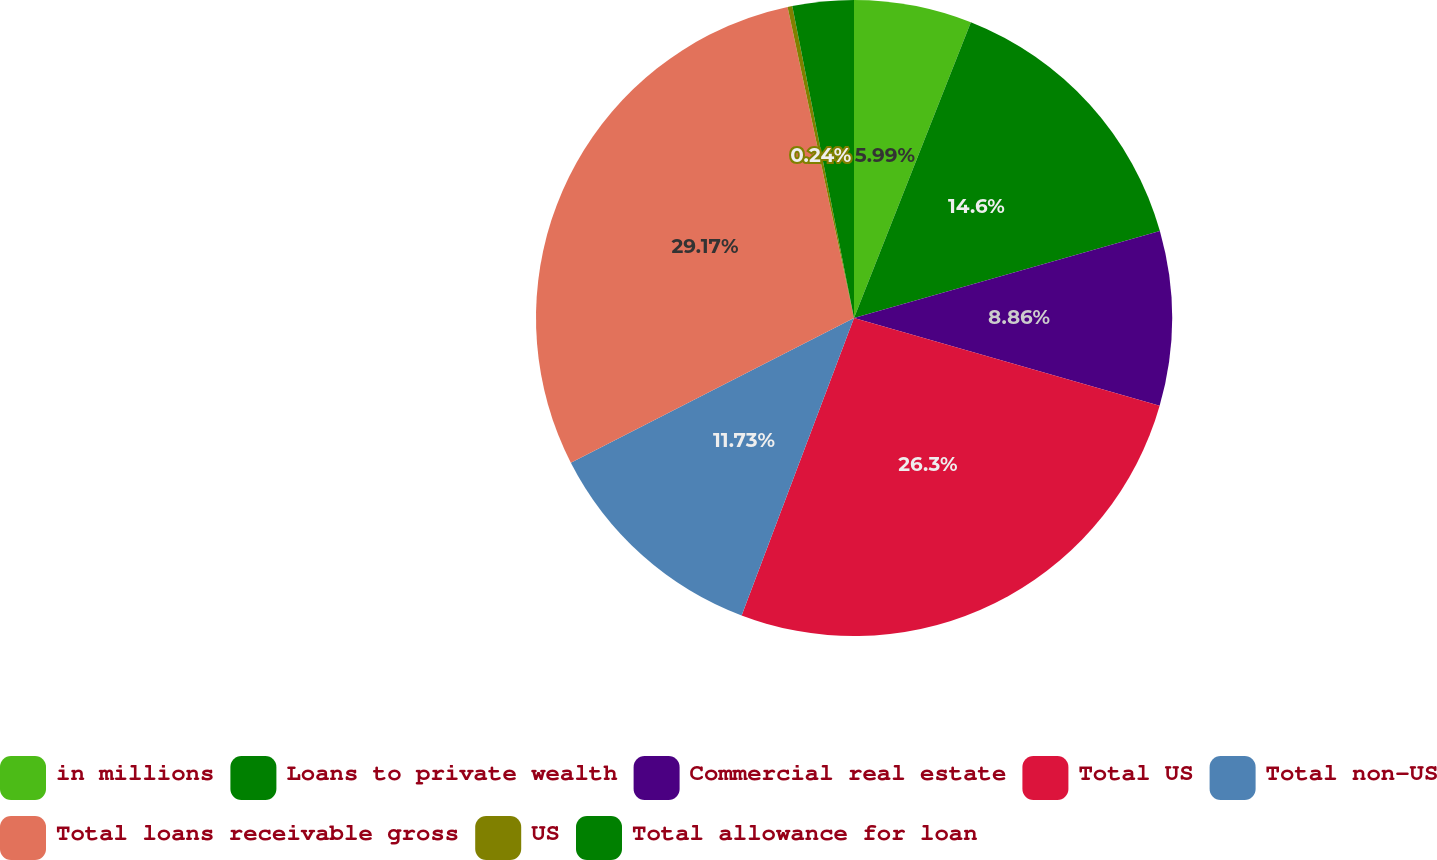<chart> <loc_0><loc_0><loc_500><loc_500><pie_chart><fcel>in millions<fcel>Loans to private wealth<fcel>Commercial real estate<fcel>Total US<fcel>Total non-US<fcel>Total loans receivable gross<fcel>US<fcel>Total allowance for loan<nl><fcel>5.99%<fcel>14.6%<fcel>8.86%<fcel>26.3%<fcel>11.73%<fcel>29.17%<fcel>0.24%<fcel>3.11%<nl></chart> 